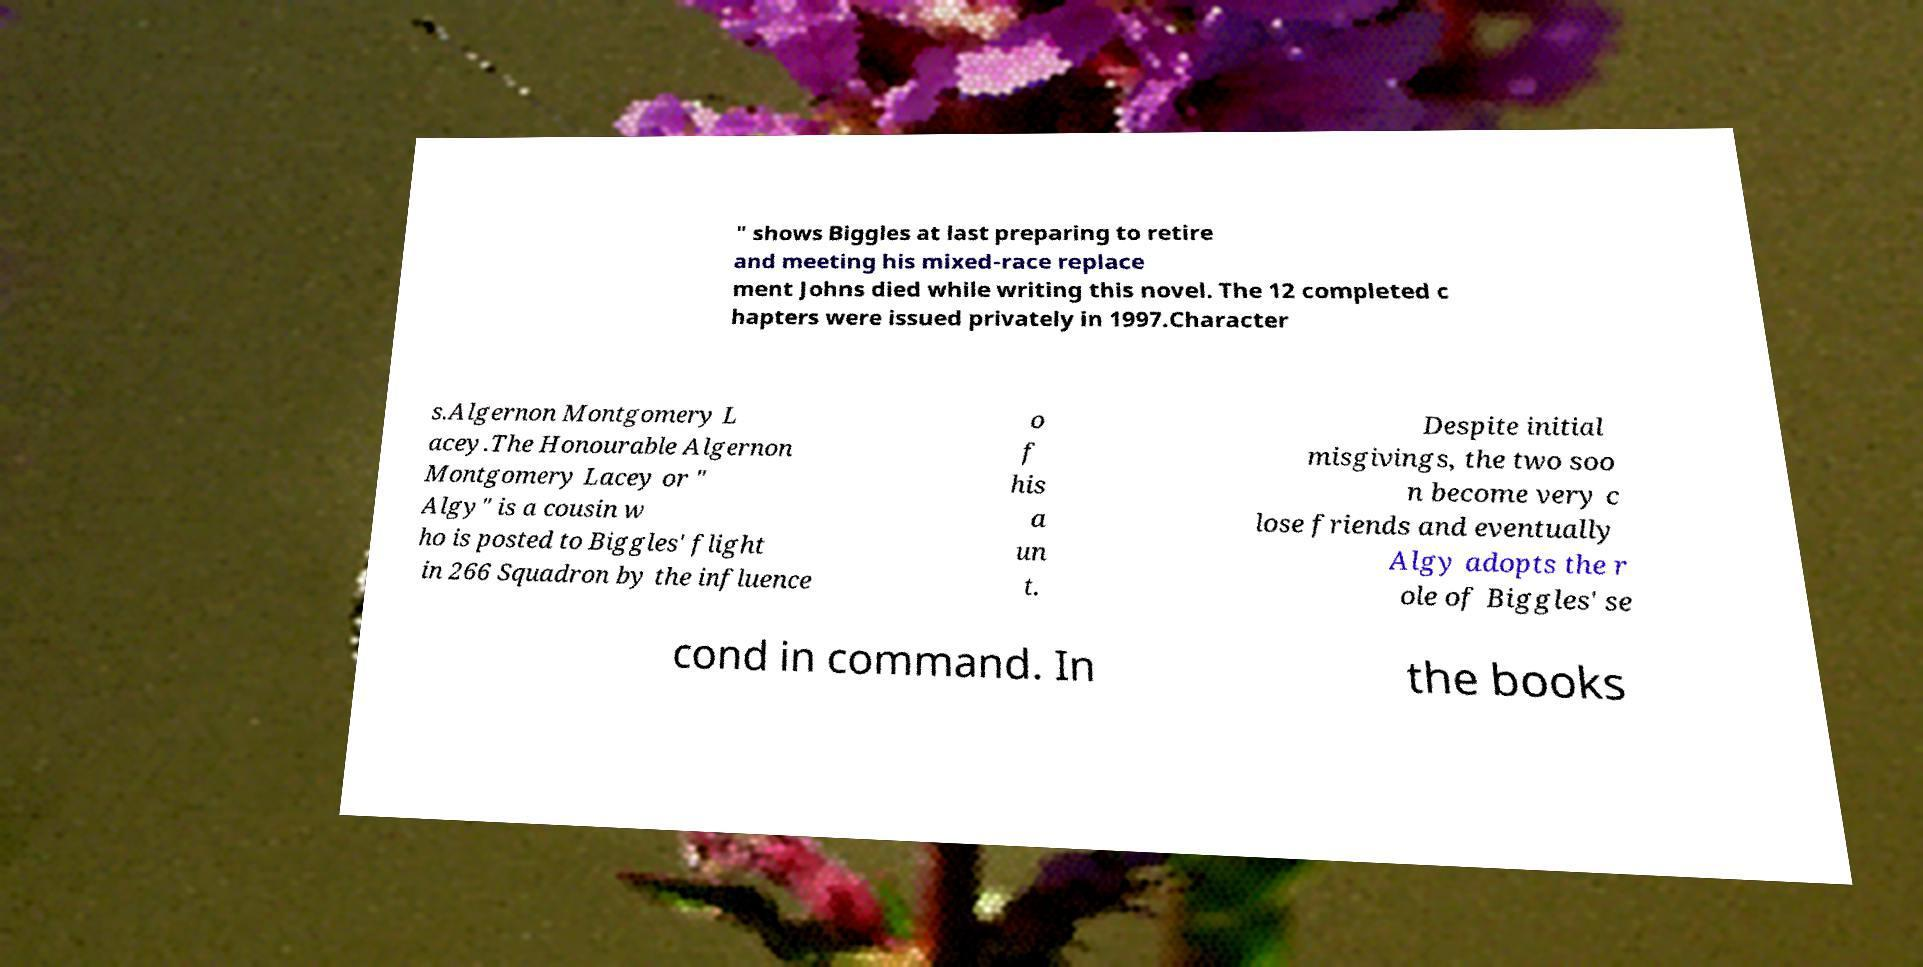There's text embedded in this image that I need extracted. Can you transcribe it verbatim? " shows Biggles at last preparing to retire and meeting his mixed-race replace ment Johns died while writing this novel. The 12 completed c hapters were issued privately in 1997.Character s.Algernon Montgomery L acey.The Honourable Algernon Montgomery Lacey or " Algy" is a cousin w ho is posted to Biggles' flight in 266 Squadron by the influence o f his a un t. Despite initial misgivings, the two soo n become very c lose friends and eventually Algy adopts the r ole of Biggles' se cond in command. In the books 